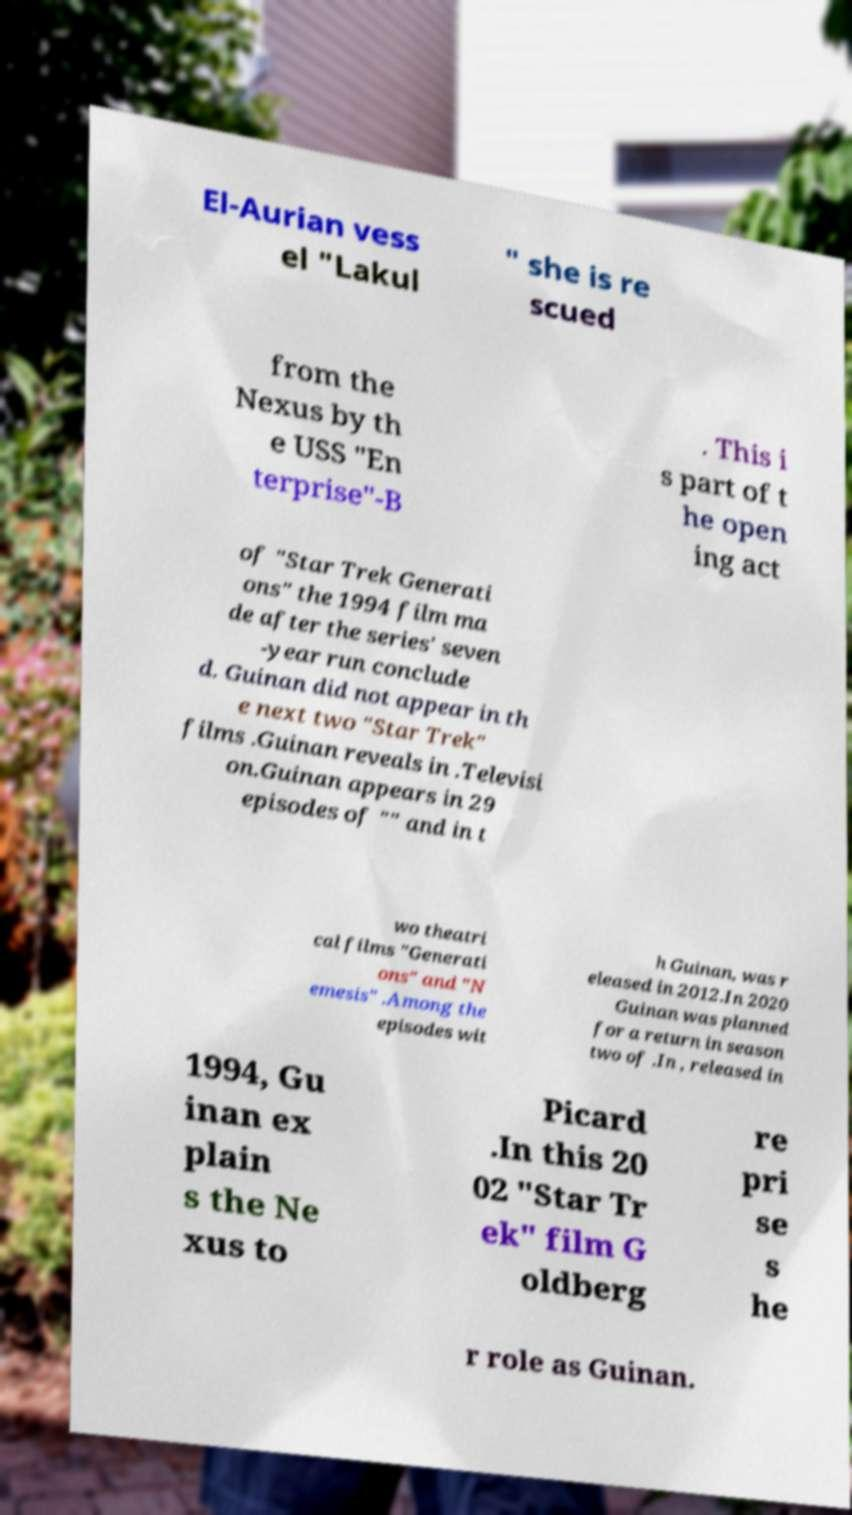I need the written content from this picture converted into text. Can you do that? El-Aurian vess el "Lakul " she is re scued from the Nexus by th e USS "En terprise"-B . This i s part of t he open ing act of "Star Trek Generati ons" the 1994 film ma de after the series' seven -year run conclude d. Guinan did not appear in th e next two "Star Trek" films .Guinan reveals in .Televisi on.Guinan appears in 29 episodes of "" and in t wo theatri cal films "Generati ons" and "N emesis" .Among the episodes wit h Guinan, was r eleased in 2012.In 2020 Guinan was planned for a return in season two of .In , released in 1994, Gu inan ex plain s the Ne xus to Picard .In this 20 02 "Star Tr ek" film G oldberg re pri se s he r role as Guinan. 